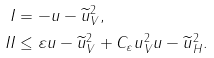Convert formula to latex. <formula><loc_0><loc_0><loc_500><loc_500>I & = - \| u - \widetilde { u } \| _ { V } ^ { 2 } , \\ I I & \leq \varepsilon \| u - \widetilde { u } \| _ { V } ^ { 2 } + C _ { \varepsilon } \| u \| _ { V } ^ { 2 } \| u - \widetilde { u } \| _ { H } ^ { 2 } .</formula> 